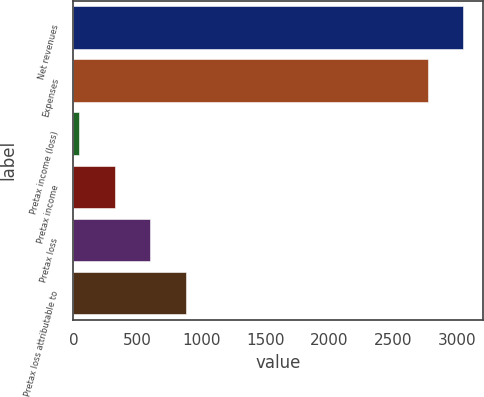Convert chart to OTSL. <chart><loc_0><loc_0><loc_500><loc_500><bar_chart><fcel>Net revenues<fcel>Expenses<fcel>Pretax income (loss)<fcel>Pretax income<fcel>Pretax loss<fcel>Pretax loss attributable to<nl><fcel>3050.3<fcel>2773<fcel>46<fcel>323.3<fcel>600.6<fcel>877.9<nl></chart> 